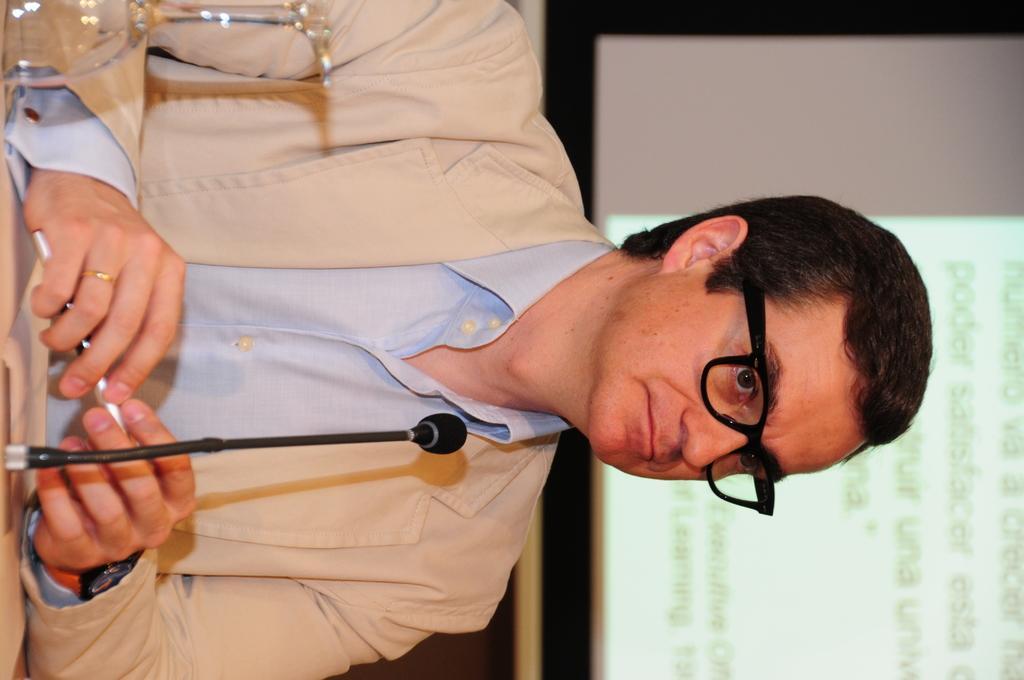In one or two sentences, can you explain what this image depicts? In the image we can see a man sitting, he is wearing clothes, spectacles and a finger ring. In front of him there is a microphone, papers and a wine glass, this is a projected screen. 